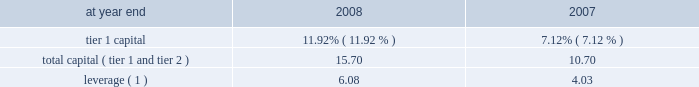Capital resources and liquidity capital resources overview capital is generally generated via earnings from operating businesses .
This is augmented through issuance of common stock , convertible preferred stock , preferred stock , subordinated debt , and equity issued through awards under employee benefit plans .
Capital is used primarily to support assets in the company 2019s businesses and to absorb unexpected market , credit or operational losses .
The company 2019s uses of capital , particularly to pay dividends and repurchase common stock , became severely restricted during the latter half of 2008 .
See 201cthe company , 201d 201cmanagement 2019s discussion and analysis 2013 events in 2008 , 201d 201ctarp and other regulatory programs , 201d 201crisk factors 201d and 201ccommon equity 201d on pages 2 , 9 , 44 , 47 and 95 , respectively .
Citigroup 2019s capital management framework is designed to ensure that citigroup and its principal subsidiaries maintain sufficient capital consistent with the company 2019s risk profile , all applicable regulatory standards and guidelines , and external rating agency considerations .
The capital management process is centrally overseen by senior management and is reviewed at the consolidated , legal entity , and country level .
Senior management oversees the capital management process of citigroup and its principal subsidiaries mainly through citigroup 2019s finance and asset and liability committee ( finalco ) .
The committee is composed of the senior-most management of citigroup for the purpose of engaging management in decision-making and related discussions on capital and liquidity items .
Among other things , the committee 2019s responsibilities include : determining the financial structure of citigroup and its principal subsidiaries ; ensuring that citigroup and its regulated entities are adequately capitalized ; determining appropriate asset levels and return hurdles for citigroup and individual businesses ; reviewing the funding and capital markets plan for citigroup ; and monitoring interest-rate risk , corporate and bank liquidity , the impact of currency translation on non-u.s .
Earnings and capital .
The finalco has established capital targets for citigroup and for significant subsidiaries .
At december 31 , 2008 , these targets exceeded the regulatory standards .
Common and preferred stock issuances as discussed under 201cevents in 2008 201d on page 9 , during 2008 , the company issued $ 45 billion in preferred stock and warrants under tarp , $ 12.5 billion of convertible preferred stock in a private offering , $ 11.7 billion of non-convertible preferred stock in public offerings , $ 3.2 billion of convertible preferred stock in public offerings , and $ 4.9 billion of common stock in public offerings .
On january 23 , 2009 , pursuant to our prior agreement with the purchasers of the $ 12.5 billion convertible preferred stock issued in the private offering , the conversion price was reset from $ 31.62 per share to $ 26.35 per share .
The reset will result in citigroup 2019s issuing approximately 79 million additional common shares if converted .
There will be no impact to net income , total stockholders 2019 equity or capital ratios due to the reset .
However , the reset will result in a reclassification from retained earnings to additional paid-in capital of $ 1.2 billion to reflect the benefit of the reset to the preferred stockholders .
Capital ratios citigroup is subject to risk-based capital ratio guidelines issued by the federal reserve board ( frb ) .
Capital adequacy is measured via two risk- based ratios , tier 1 and total capital ( tier 1 + tier 2 capital ) .
Tier 1 capital is considered core capital while total capital also includes other items such as subordinated debt and loan loss reserves .
Both measures of capital are stated as a percentage of risk-weighted assets .
Risk-weighted assets are measured primarily on their perceived credit risk and include certain off-balance-sheet exposures , such as unfunded loan commitments and letters of credit , and the notional amounts of derivative and foreign- exchange contracts .
Citigroup is also subject to the leverage ratio requirement , a non-risk-based asset ratio , which is defined as tier 1 capital as a percentage of adjusted average assets .
To be 201cwell capitalized 201d under federal bank regulatory agency definitions , a bank holding company must have a tier 1 capital ratio of at least 6% ( 6 % ) , a total capital ratio of at least 10% ( 10 % ) , and a leverage ratio of at least 3% ( 3 % ) , and not be subject to an frb directive to maintain higher capital levels .
As noted in the table , citigroup maintained a 201cwell capitalized 201d position during both 2008 and 2007 .
Citigroup regulatory capital ratios at year end 2008 2007 .
Leverage ( 1 ) 6.08 4.03 ( 1 ) tier 1 capital divided by adjusted average assets .
Events occurring during 2008 , including the transactions with the u.s .
Government , affected citigroup 2019s capital ratios , and any additional u.s .
Government financial involvement with the company could further impact the company 2019s capital ratios .
In addition , future operations will affect capital levels , and changes that the fasb has proposed regarding off-balance-sheet assets , consolidation and sale treatment could also have an impact on capital ratios .
See also note 23 to the consolidated financial statements on page 175 , including 201cfunding liquidity facilities and subordinate interests . 201d .
What was the percent of the change in the citigroup regulatory capital ratios total capital ( tier 1 and tier 2 ) from 2007 to 2008? 
Computations: ((15.70 - 10.70) / 10.70)
Answer: 0.46729. 